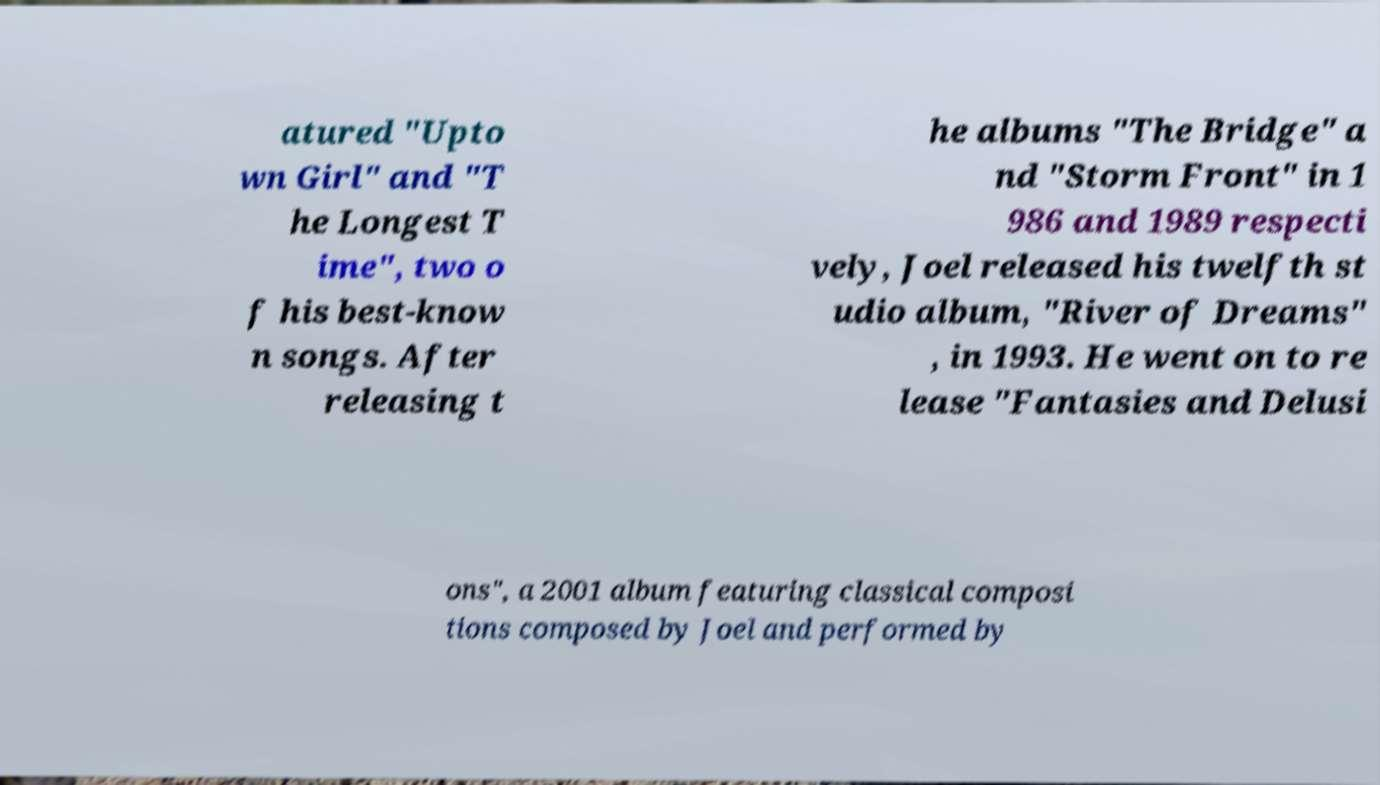For documentation purposes, I need the text within this image transcribed. Could you provide that? atured "Upto wn Girl" and "T he Longest T ime", two o f his best-know n songs. After releasing t he albums "The Bridge" a nd "Storm Front" in 1 986 and 1989 respecti vely, Joel released his twelfth st udio album, "River of Dreams" , in 1993. He went on to re lease "Fantasies and Delusi ons", a 2001 album featuring classical composi tions composed by Joel and performed by 